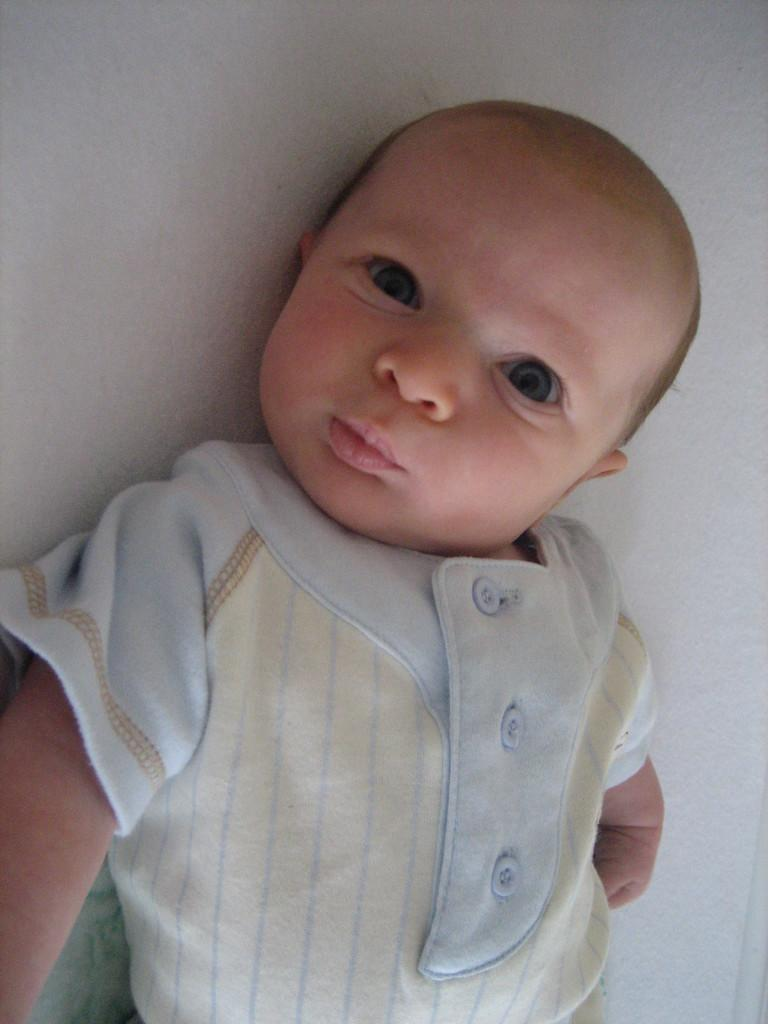What is the main subject of the image? The main subject of the image is a child. What is the child doing in the image? The child is lying on a surface in the image. What type of box can be seen in the image? There is no box present in the image. What type of fang is visible in the image? There are no fangs present in the image. 